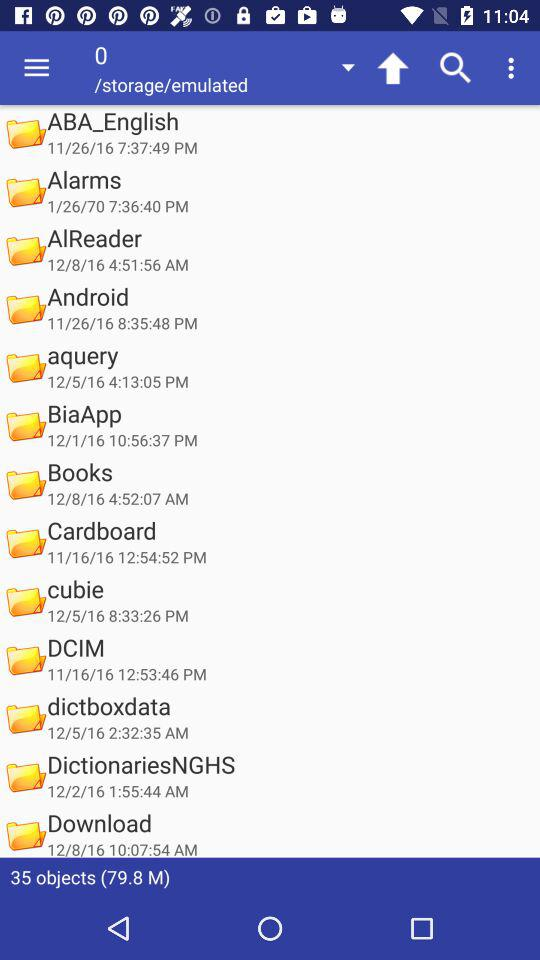How many objects are there in total? There are total 35 objects. 